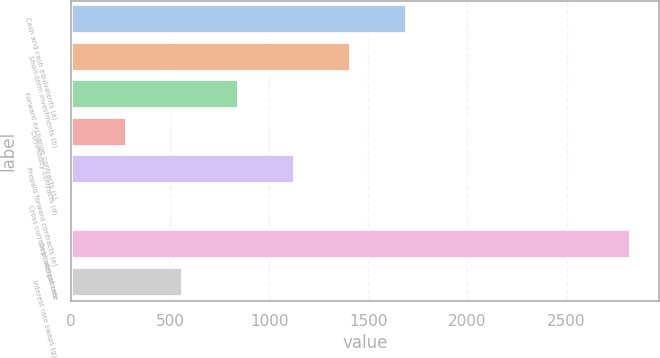Convert chart. <chart><loc_0><loc_0><loc_500><loc_500><bar_chart><fcel>Cash and cash equivalents (a)<fcel>Short-term investments (b)<fcel>Forward exchange contracts (c)<fcel>Commodity contracts (d)<fcel>Prepaid forward contracts (e)<fcel>Cross currency interest rate<fcel>Debt obligations<fcel>Interest rate swaps (g)<nl><fcel>1694.8<fcel>1412.5<fcel>847.9<fcel>283.3<fcel>1130.2<fcel>1<fcel>2824<fcel>565.6<nl></chart> 